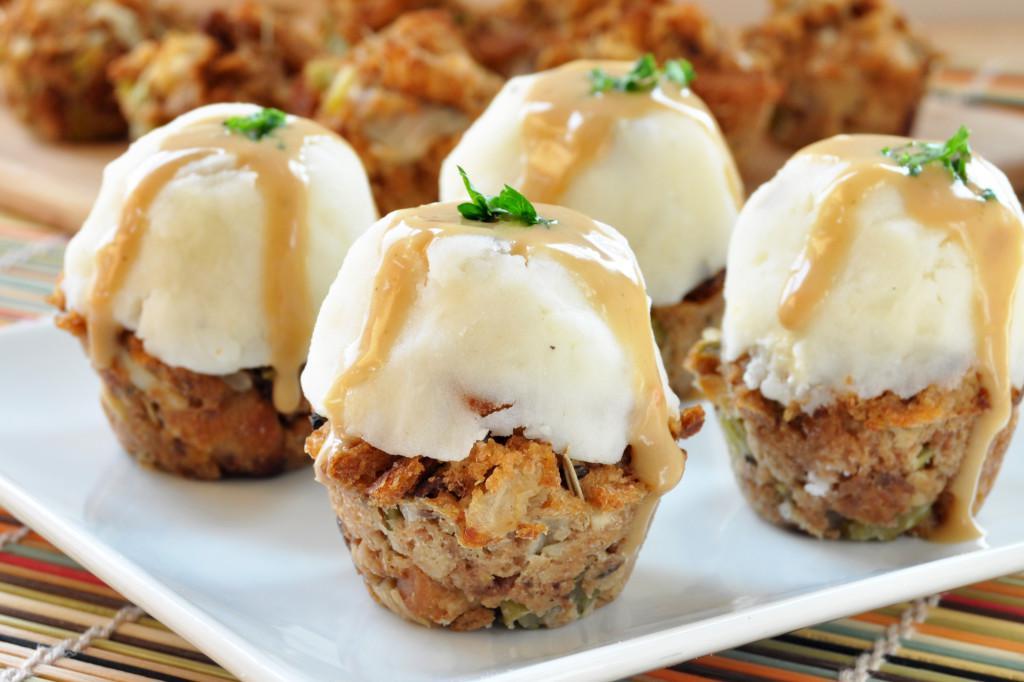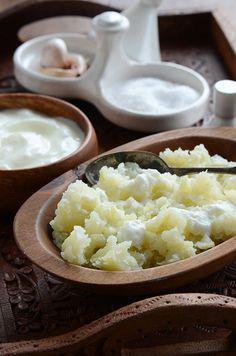The first image is the image on the left, the second image is the image on the right. Given the left and right images, does the statement "An image shows a fork resting on a white plate of food." hold true? Answer yes or no. No. The first image is the image on the left, the second image is the image on the right. Examine the images to the left and right. Is the description "A silver fork is sitting near the food in the image on the right." accurate? Answer yes or no. No. 